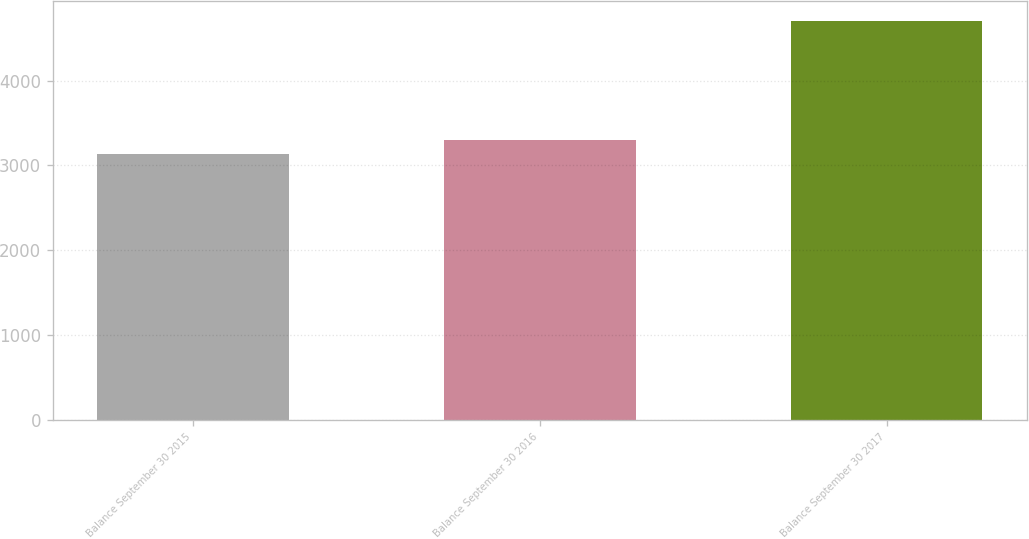Convert chart. <chart><loc_0><loc_0><loc_500><loc_500><bar_chart><fcel>Balance September 30 2015<fcel>Balance September 30 2016<fcel>Balance September 30 2017<nl><fcel>3138<fcel>3294.6<fcel>4704<nl></chart> 